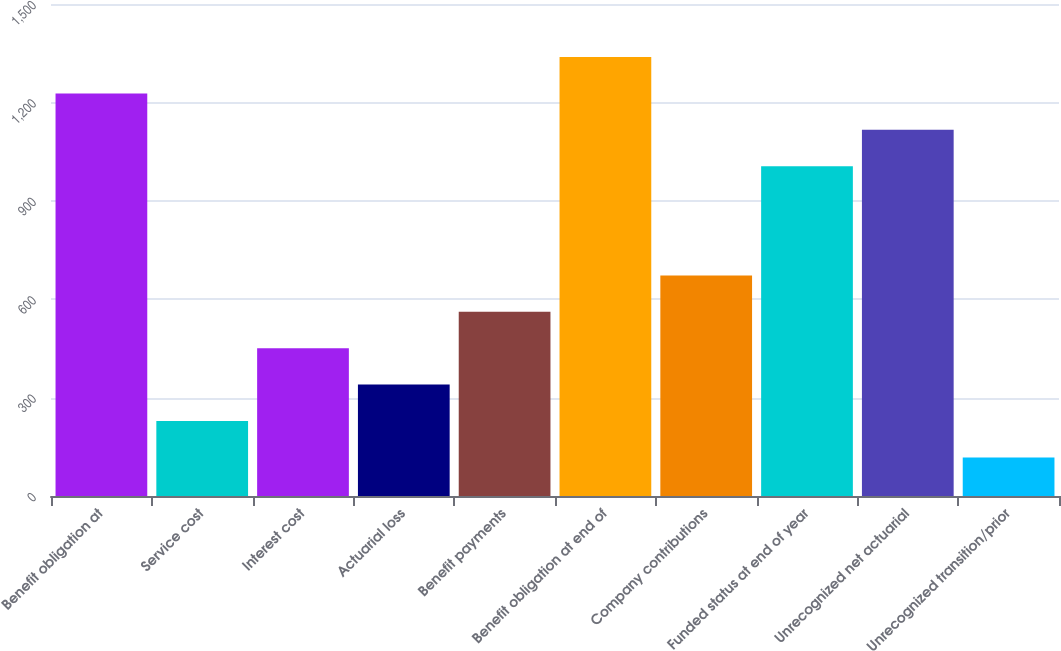<chart> <loc_0><loc_0><loc_500><loc_500><bar_chart><fcel>Benefit obligation at<fcel>Service cost<fcel>Interest cost<fcel>Actuarial loss<fcel>Benefit payments<fcel>Benefit obligation at end of<fcel>Company contributions<fcel>Funded status at end of year<fcel>Unrecognized net actuarial<fcel>Unrecognized transition/prior<nl><fcel>1227.27<fcel>228.66<fcel>450.57<fcel>339.62<fcel>561.52<fcel>1338.22<fcel>672.48<fcel>1005.36<fcel>1116.32<fcel>117.7<nl></chart> 